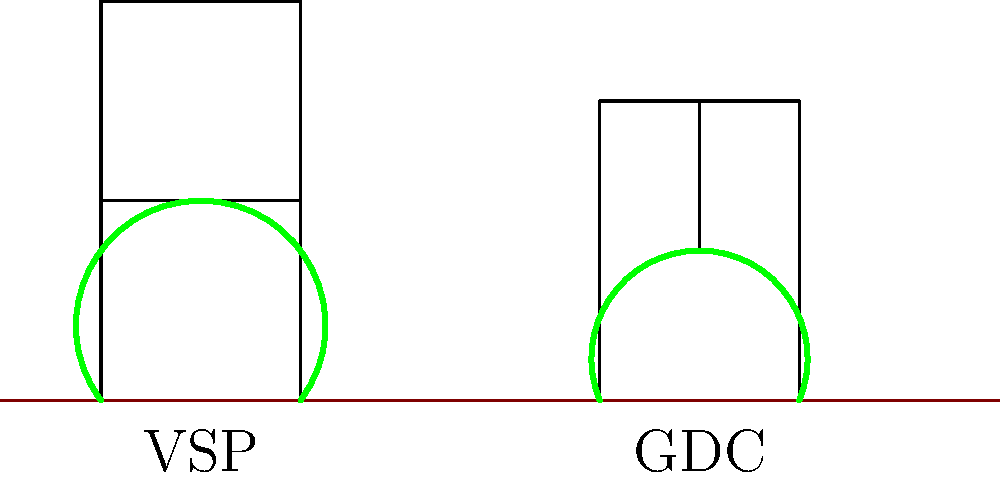The diagram shows two common grapevine trellis systems: Vertical Shoot Positioning (VSP) and Geneva Double Curtain (GDC). Based on the illustration, which system is likely to provide better sunlight exposure and air circulation for the grapevines? To determine which trellis system provides better sunlight exposure and air circulation, we need to analyze the structure and vine arrangement in each system:

1. Vertical Shoot Positioning (VSP):
   - Vines are trained to grow vertically between two wires.
   - The canopy is relatively compact and narrow.
   - Shoots are positioned upward, creating a wall-like structure.

2. Geneva Double Curtain (GDC):
   - Vines are trained to grow on a Y-shaped trellis.
   - The canopy is split into two curtains, separated by a gap in the middle.
   - Shoots hang downward on either side of the central trunk.

Comparing the two systems:

a) Sunlight exposure:
   - GDC allows more sunlight to penetrate through the gap between the two curtains.
   - The divided canopy in GDC increases the total leaf surface area exposed to sunlight.
   - VSP has a more compact canopy, which may lead to some shading of lower leaves.

b) Air circulation:
   - GDC's open structure allows better air movement between and through the divided canopy.
   - The gap in the GDC system promotes better ventilation, reducing humidity and disease pressure.
   - VSP's more compact structure may restrict air movement, especially in the center of the canopy.

Based on these factors, the Geneva Double Curtain (GDC) system is likely to provide better sunlight exposure and air circulation for the grapevines.
Answer: Geneva Double Curtain (GDC) 